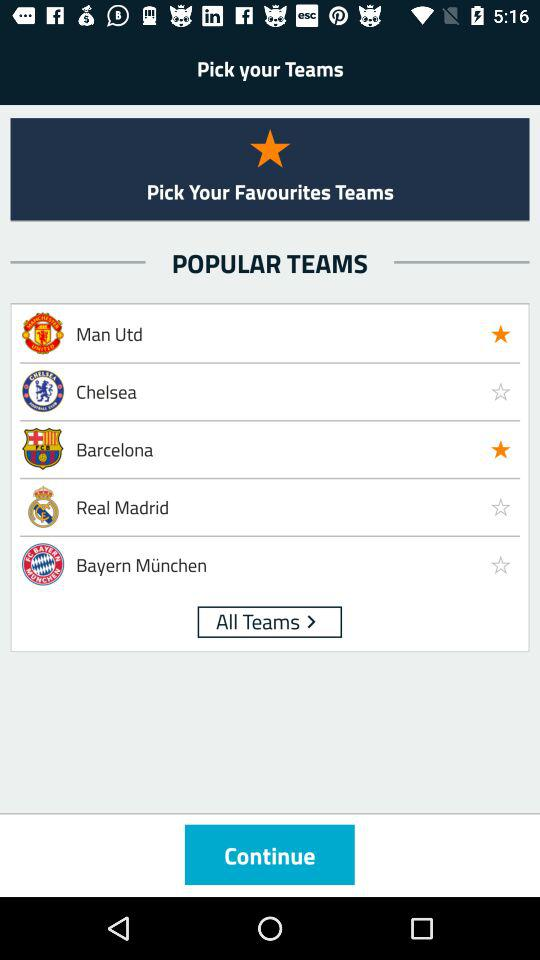Which are your favourite teams? The favourite teams are "Man Utd" and "Barcelona". 